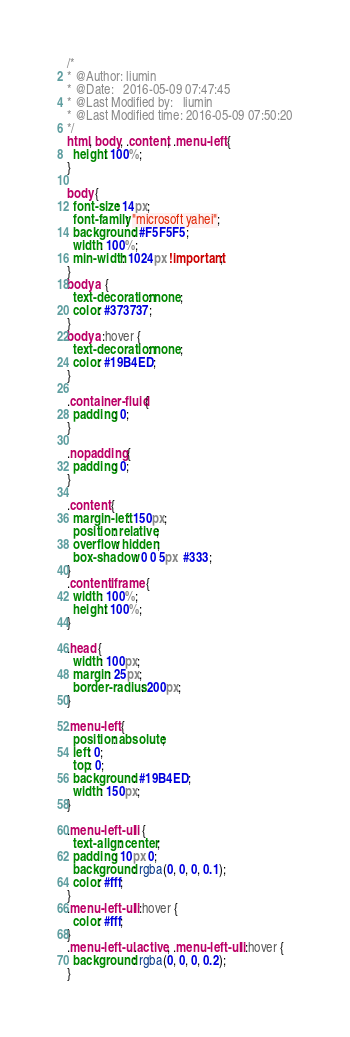<code> <loc_0><loc_0><loc_500><loc_500><_CSS_>/*
* @Author: liumin
* @Date:   2016-05-09 07:47:45
* @Last Modified by:   liumin
* @Last Modified time: 2016-05-09 07:50:20
*/
html, body, .content, .menu-left {
  height: 100%;
}

body {
  font-size: 14px;
  font-family: "microsoft yahei";
  background: #F5F5F5;
  width: 100%;
  min-width: 1024px !important;
}
body a {
  text-decoration: none;
  color: #373737;
}
body a:hover {
  text-decoration: none;
  color: #19B4ED;
}

.container-fluid {
  padding: 0;
}

.nopadding {
  padding: 0;
}

.content {
  margin-left: 150px;
  position: relative;
  overflow: hidden;
  box-shadow: 0 0 5px  #333;
}
.content iframe {
  width: 100%;
  height: 100%;
}

.head {
  width: 100px;
  margin: 25px;
  border-radius: 200px;
}

.menu-left {
  position: absolute;
  left: 0;
  top: 0;
  background: #19B4ED;
  width: 150px;
}

.menu-left-ul li {
  text-align: center;
  padding: 10px 0;
  background: rgba(0, 0, 0, 0.1);
  color: #fff;
}
.menu-left-ul li:hover {
  color: #fff;
}
.menu-left-ul .active, .menu-left-ul li:hover {
  background: rgba(0, 0, 0, 0.2);
}
</code> 